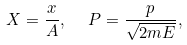<formula> <loc_0><loc_0><loc_500><loc_500>X = \frac { x } { A } , \ \ P = \frac { p } { \sqrt { 2 m E } } ,</formula> 